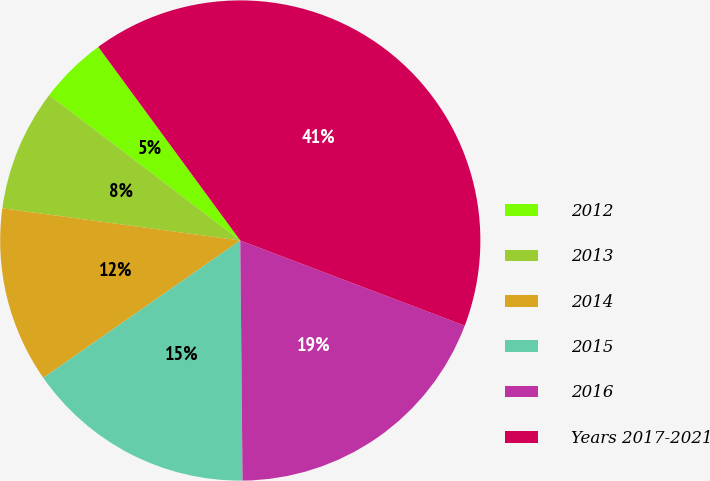Convert chart to OTSL. <chart><loc_0><loc_0><loc_500><loc_500><pie_chart><fcel>2012<fcel>2013<fcel>2014<fcel>2015<fcel>2016<fcel>Years 2017-2021<nl><fcel>4.58%<fcel>8.21%<fcel>11.83%<fcel>15.46%<fcel>19.08%<fcel>40.84%<nl></chart> 